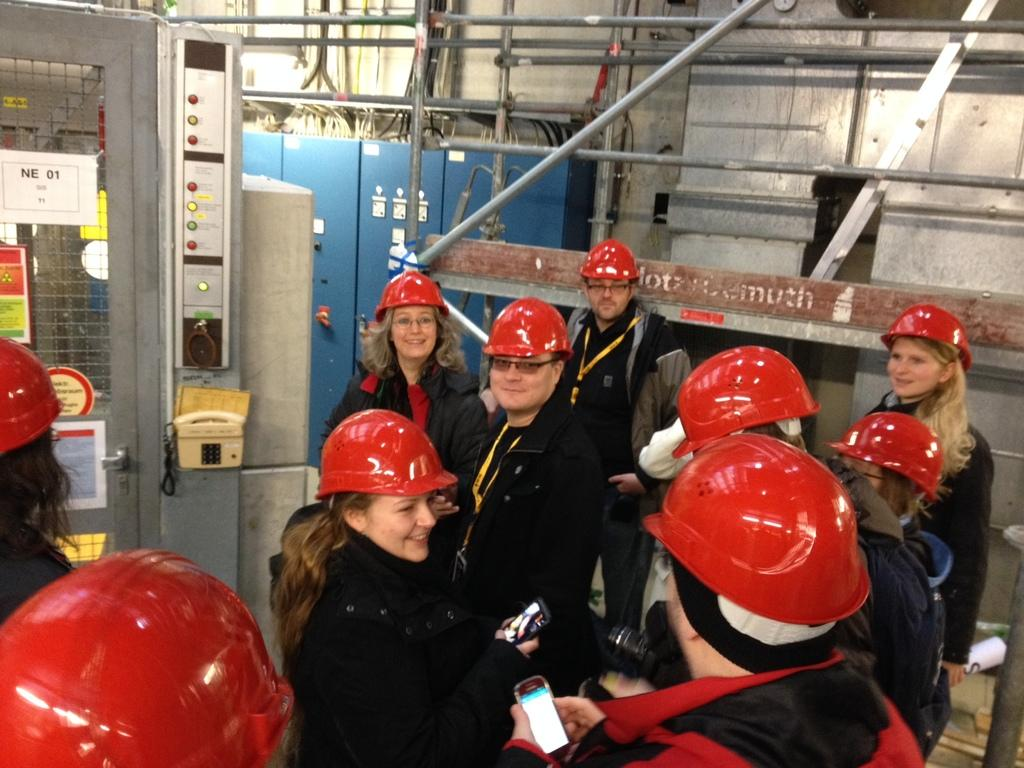What can be seen in the image? There is a group of people in the image. What are the people wearing? The people are wearing black color jackets and red color helmets. What are the people doing in the image? The people are standing. What else is present in the image besides the people? There are machines and a pipeline in the image. What type of yard waste can be seen in the image? There is no yard waste present in the image. How does the control panel operate the machines in the image? There is no control panel visible in the image, so it is not possible to determine how the machines operate. 